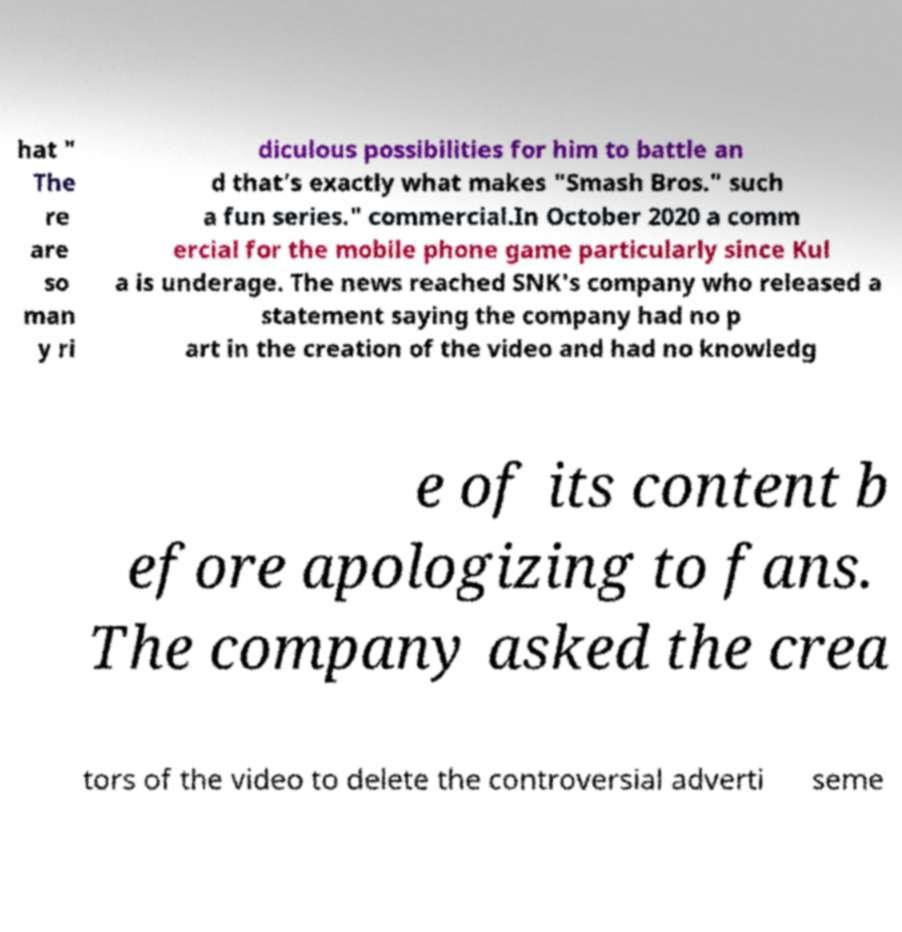Please identify and transcribe the text found in this image. hat " The re are so man y ri diculous possibilities for him to battle an d that’s exactly what makes "Smash Bros." such a fun series." commercial.In October 2020 a comm ercial for the mobile phone game particularly since Kul a is underage. The news reached SNK's company who released a statement saying the company had no p art in the creation of the video and had no knowledg e of its content b efore apologizing to fans. The company asked the crea tors of the video to delete the controversial adverti seme 